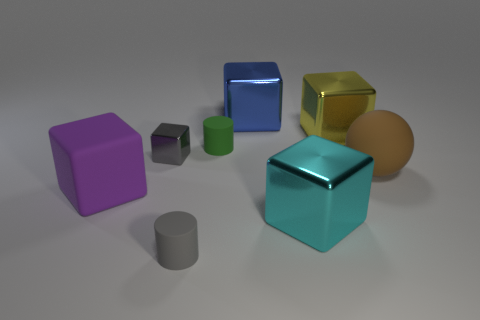What is the material of the tiny object left of the matte cylinder that is in front of the large rubber thing that is to the right of the blue shiny object?
Ensure brevity in your answer.  Metal. How many objects are small blue rubber blocks or rubber blocks that are in front of the gray metal cube?
Your answer should be compact. 1. Do the matte cylinder in front of the purple matte cube and the tiny shiny thing have the same color?
Provide a short and direct response. Yes. Are there more rubber objects to the right of the yellow metal cube than green cylinders that are in front of the big purple cube?
Your response must be concise. Yes. Is there any other thing that has the same color as the big rubber sphere?
Keep it short and to the point. No. How many objects are large cyan objects or blue metallic blocks?
Your answer should be compact. 2. There is a cylinder right of the gray rubber cylinder; does it have the same size as the big cyan thing?
Make the answer very short. No. How many other objects are the same size as the yellow metallic thing?
Your response must be concise. 4. Are any blue shiny things visible?
Offer a terse response. Yes. What is the size of the rubber cylinder behind the tiny gray metallic block behind the big purple rubber object?
Provide a short and direct response. Small. 